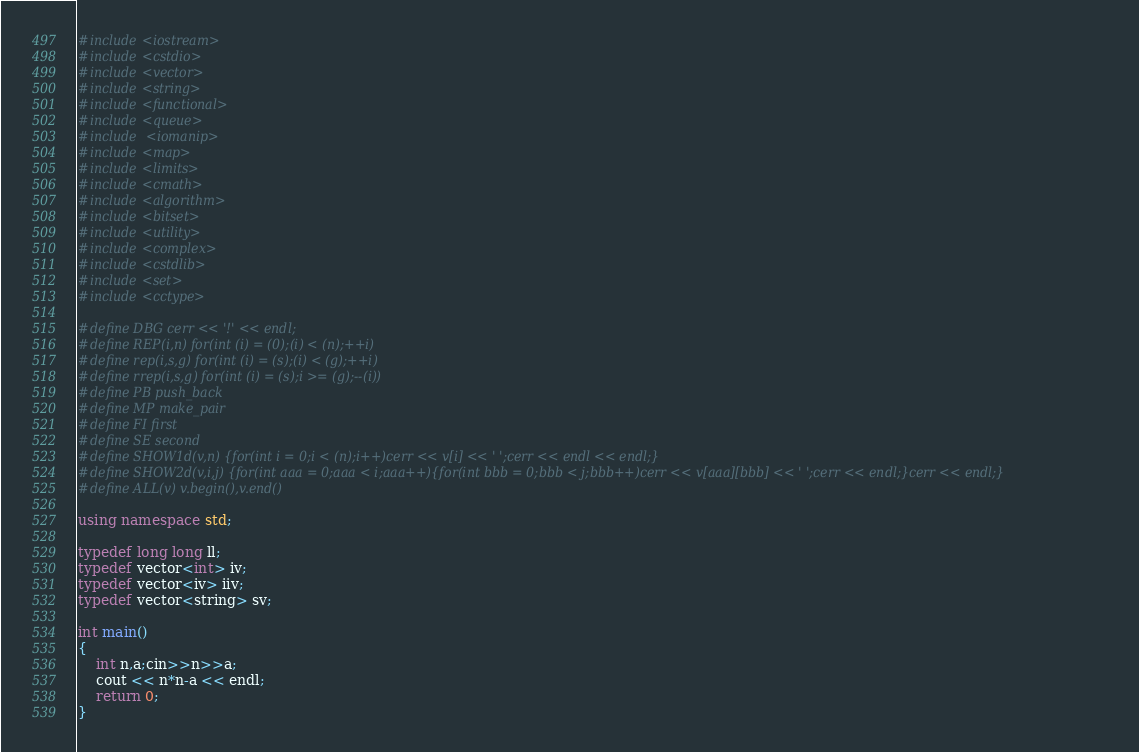Convert code to text. <code><loc_0><loc_0><loc_500><loc_500><_C++_>#include<iostream>
#include<cstdio>
#include<vector>
#include<string>
#include<functional>
#include<queue>
#include <iomanip>
#include<map>
#include<limits>
#include<cmath>
#include<algorithm>
#include<bitset>
#include<utility>
#include<complex>
#include<cstdlib>
#include<set>
#include<cctype>

#define DBG cerr << '!' << endl;
#define REP(i,n) for(int (i) = (0);(i) < (n);++i)
#define rep(i,s,g) for(int (i) = (s);(i) < (g);++i)
#define rrep(i,s,g) for(int (i) = (s);i >= (g);--(i))
#define PB push_back
#define MP make_pair
#define FI first
#define SE second
#define SHOW1d(v,n) {for(int i = 0;i < (n);i++)cerr << v[i] << ' ';cerr << endl << endl;}
#define SHOW2d(v,i,j) {for(int aaa = 0;aaa < i;aaa++){for(int bbb = 0;bbb < j;bbb++)cerr << v[aaa][bbb] << ' ';cerr << endl;}cerr << endl;}
#define ALL(v) v.begin(),v.end()

using namespace std;

typedef long long ll;
typedef vector<int> iv;
typedef vector<iv> iiv;
typedef vector<string> sv;

int main()
{
	int n,a;cin>>n>>a;
	cout << n*n-a << endl;
	return 0;
}</code> 